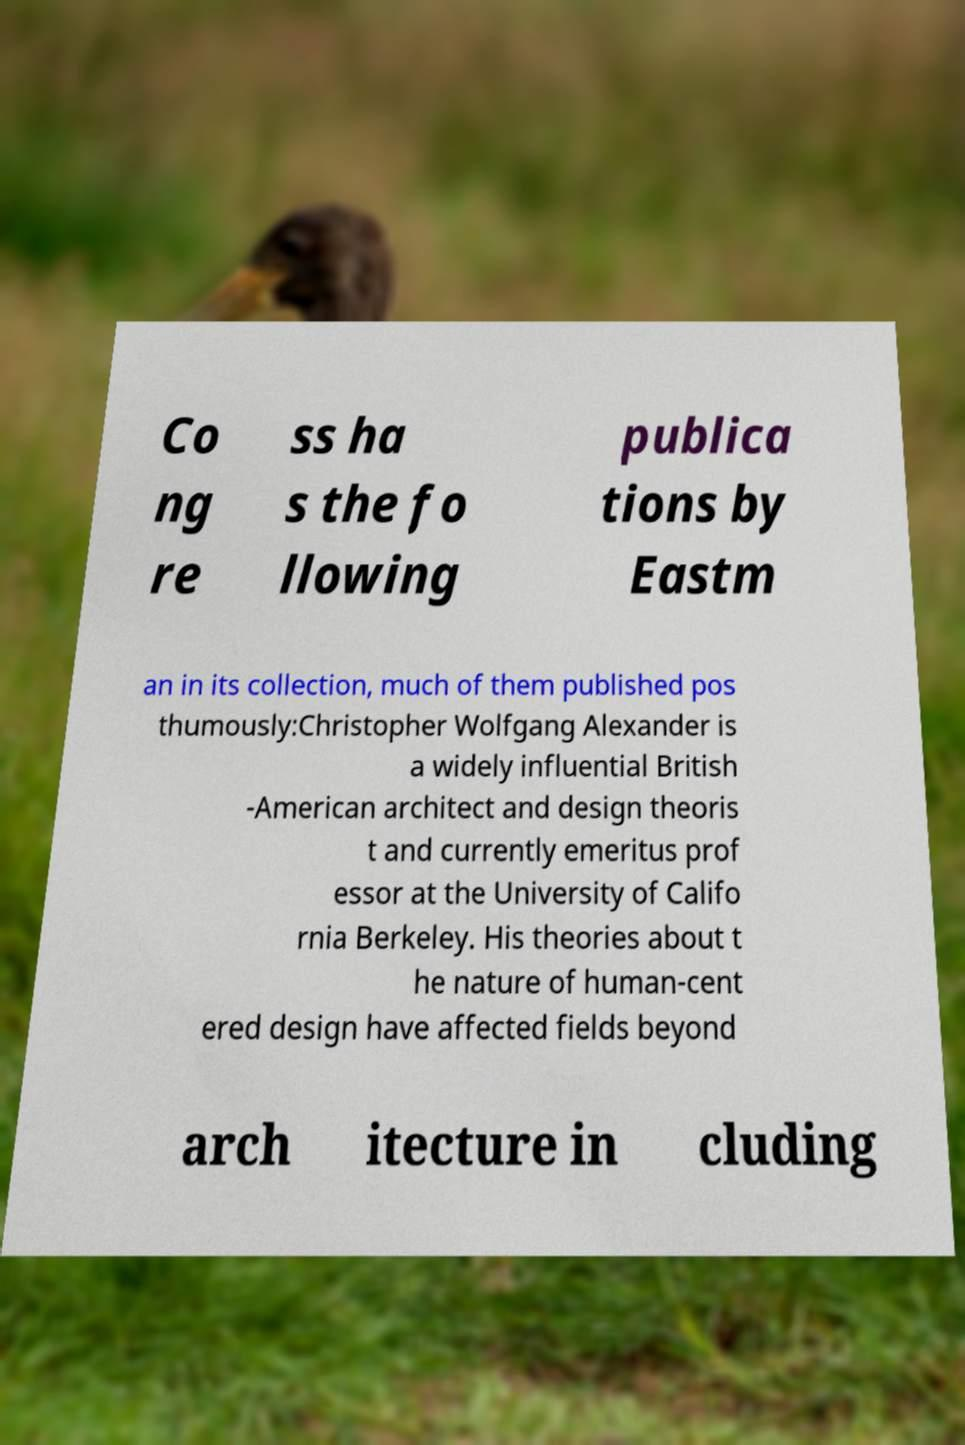Can you read and provide the text displayed in the image?This photo seems to have some interesting text. Can you extract and type it out for me? Co ng re ss ha s the fo llowing publica tions by Eastm an in its collection, much of them published pos thumously:Christopher Wolfgang Alexander is a widely influential British -American architect and design theoris t and currently emeritus prof essor at the University of Califo rnia Berkeley. His theories about t he nature of human-cent ered design have affected fields beyond arch itecture in cluding 